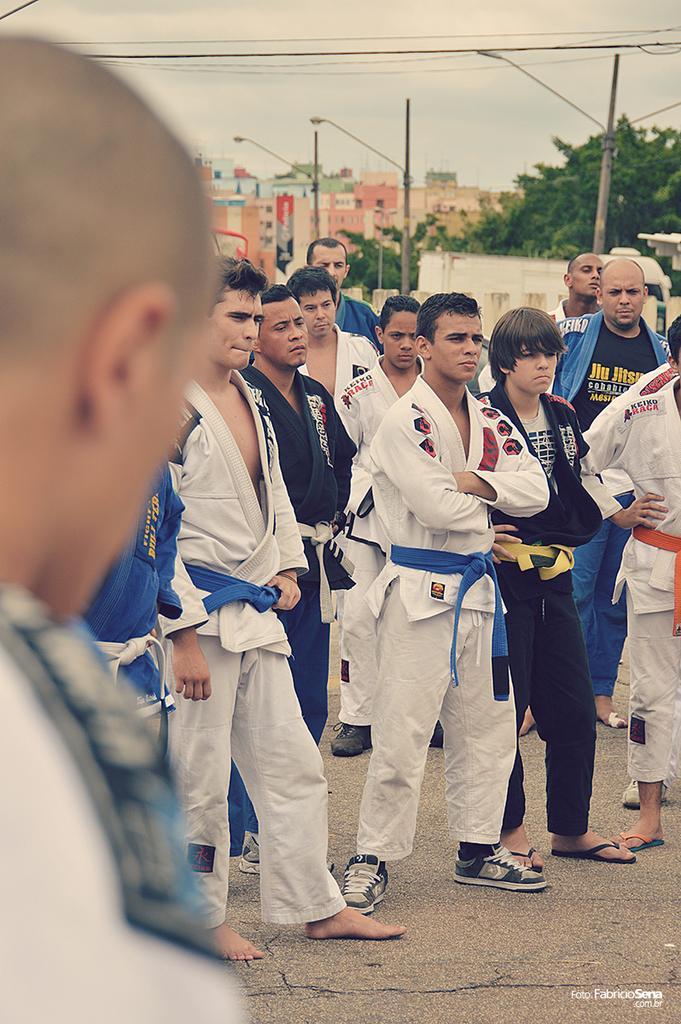How many people are in the image? There is a group of people in the image, but the exact number is not specified. What is the surface on which the people are standing? The people are standing on the ground. What structures can be seen in the image? There are poles, buildings, and trees in the image. Are there any man-made objects in the image? Yes, there are wires in the image. What can be seen in the background of the image? The sky is visible in the background of the image. Where is the library located in the image? There is no library present in the image. Is there a crown visible on any of the people in the image? No, there is no crown visible on any of the people in the image. 